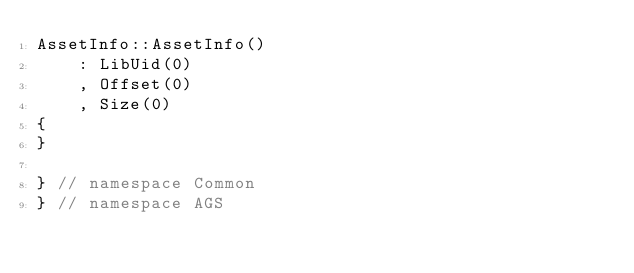Convert code to text. <code><loc_0><loc_0><loc_500><loc_500><_C++_>AssetInfo::AssetInfo()
    : LibUid(0)
    , Offset(0)
    , Size(0)
{
}

} // namespace Common
} // namespace AGS
</code> 